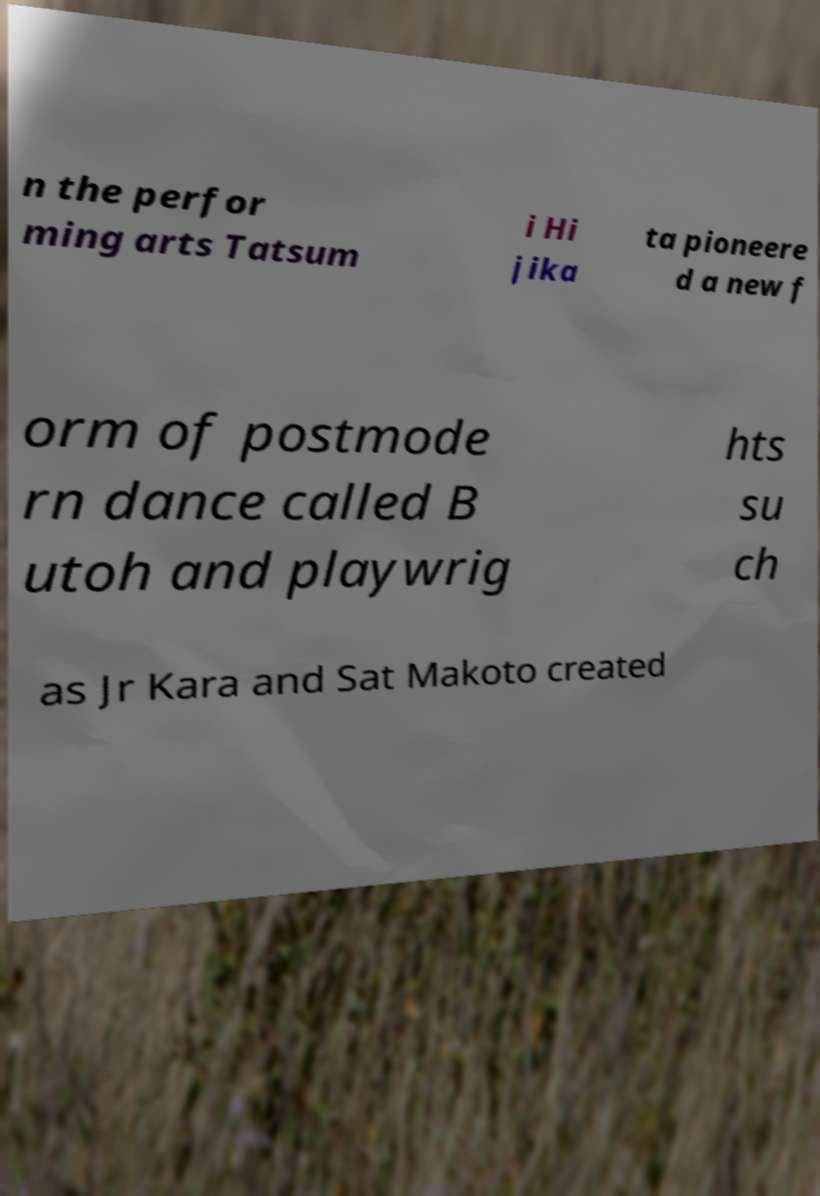Can you accurately transcribe the text from the provided image for me? n the perfor ming arts Tatsum i Hi jika ta pioneere d a new f orm of postmode rn dance called B utoh and playwrig hts su ch as Jr Kara and Sat Makoto created 